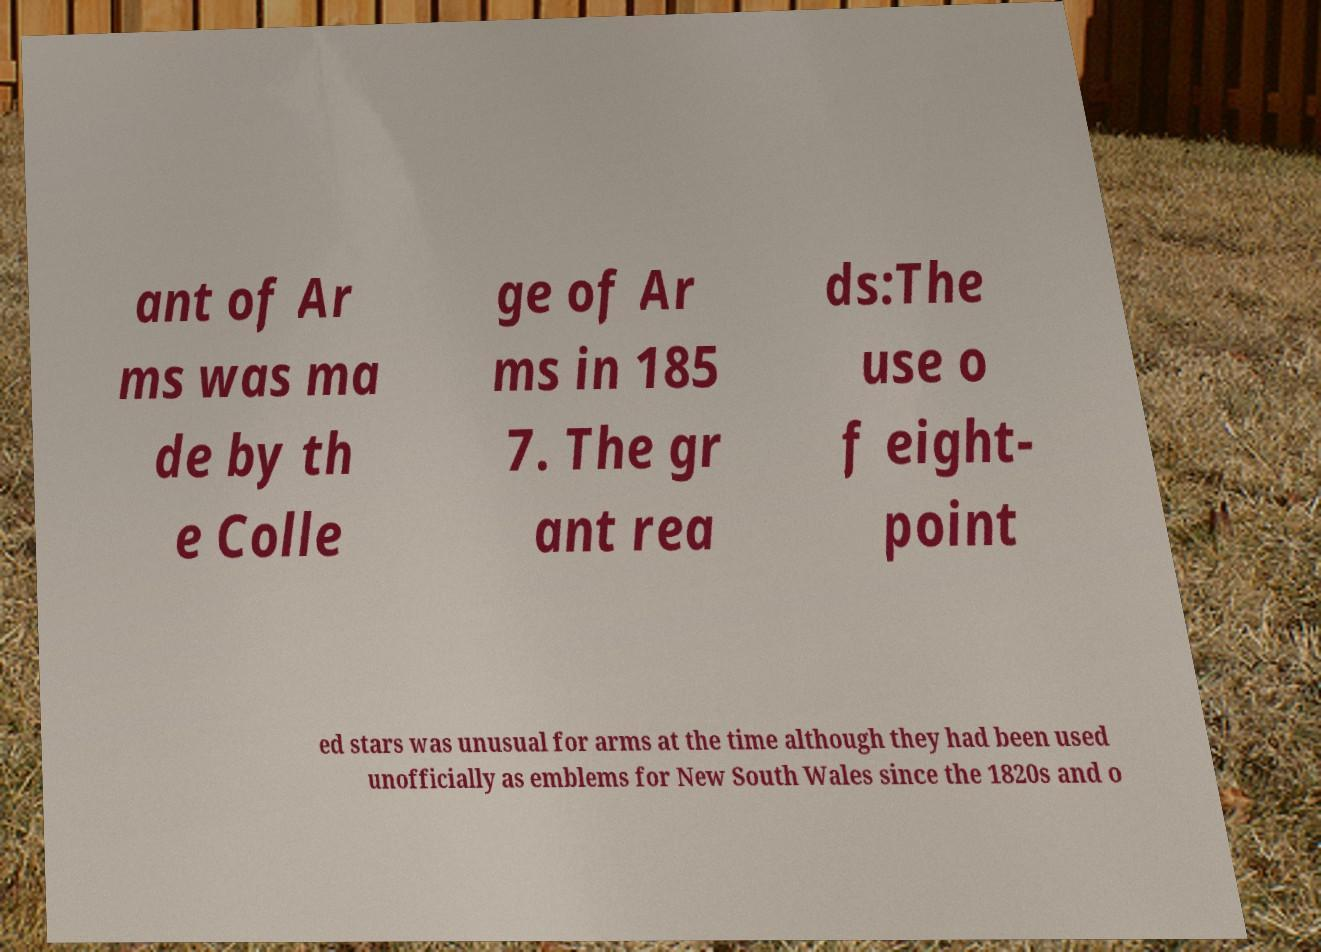Please identify and transcribe the text found in this image. ant of Ar ms was ma de by th e Colle ge of Ar ms in 185 7. The gr ant rea ds:The use o f eight- point ed stars was unusual for arms at the time although they had been used unofficially as emblems for New South Wales since the 1820s and o 